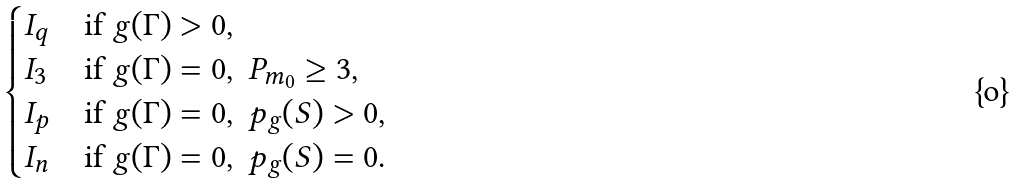Convert formula to latex. <formula><loc_0><loc_0><loc_500><loc_500>\begin{cases} I _ { q } & \text {if} \ g ( \Gamma ) > 0 , \\ I _ { 3 } & \text {if} \ g ( \Gamma ) = 0 , \ P _ { m _ { 0 } } \geq 3 , \\ I _ { p } & \text {if} \ g ( \Gamma ) = 0 , \ p _ { g } ( S ) > 0 , \\ I _ { n } & \text {if} \ g ( \Gamma ) = 0 , \ p _ { g } ( S ) = 0 . \\ \end{cases}</formula> 